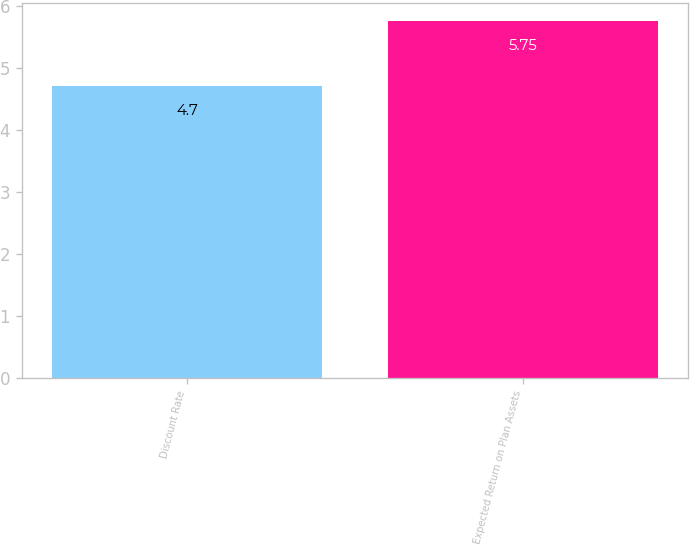Convert chart to OTSL. <chart><loc_0><loc_0><loc_500><loc_500><bar_chart><fcel>Discount Rate<fcel>Expected Return on Plan Assets<nl><fcel>4.7<fcel>5.75<nl></chart> 